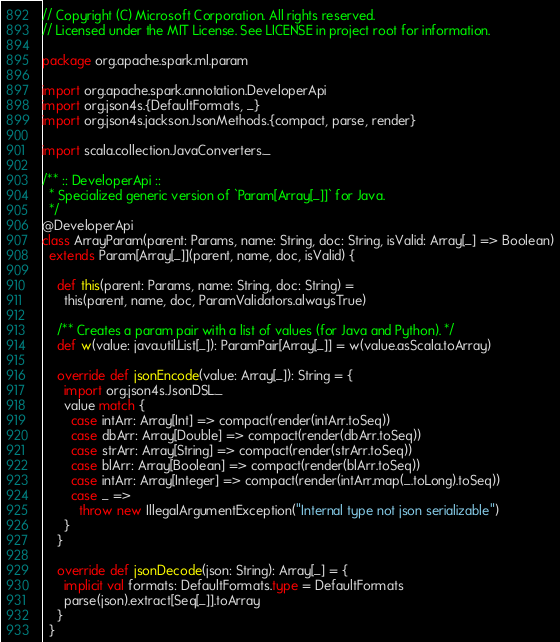<code> <loc_0><loc_0><loc_500><loc_500><_Scala_>// Copyright (C) Microsoft Corporation. All rights reserved.
// Licensed under the MIT License. See LICENSE in project root for information.

package org.apache.spark.ml.param

import org.apache.spark.annotation.DeveloperApi
import org.json4s.{DefaultFormats, _}
import org.json4s.jackson.JsonMethods.{compact, parse, render}

import scala.collection.JavaConverters._

/** :: DeveloperApi ::
  * Specialized generic version of `Param[Array[_]]` for Java.
  */
@DeveloperApi
class ArrayParam(parent: Params, name: String, doc: String, isValid: Array[_] => Boolean)
  extends Param[Array[_]](parent, name, doc, isValid) {

    def this(parent: Params, name: String, doc: String) =
      this(parent, name, doc, ParamValidators.alwaysTrue)

    /** Creates a param pair with a list of values (for Java and Python). */
    def w(value: java.util.List[_]): ParamPair[Array[_]] = w(value.asScala.toArray)

    override def jsonEncode(value: Array[_]): String = {
      import org.json4s.JsonDSL._
      value match {
        case intArr: Array[Int] => compact(render(intArr.toSeq))
        case dbArr: Array[Double] => compact(render(dbArr.toSeq))
        case strArr: Array[String] => compact(render(strArr.toSeq))
        case blArr: Array[Boolean] => compact(render(blArr.toSeq))
        case intArr: Array[Integer] => compact(render(intArr.map(_.toLong).toSeq))
        case _ =>
          throw new IllegalArgumentException("Internal type not json serializable")
      }
    }

    override def jsonDecode(json: String): Array[_] = {
      implicit val formats: DefaultFormats.type = DefaultFormats
      parse(json).extract[Seq[_]].toArray
    }
  }
</code> 